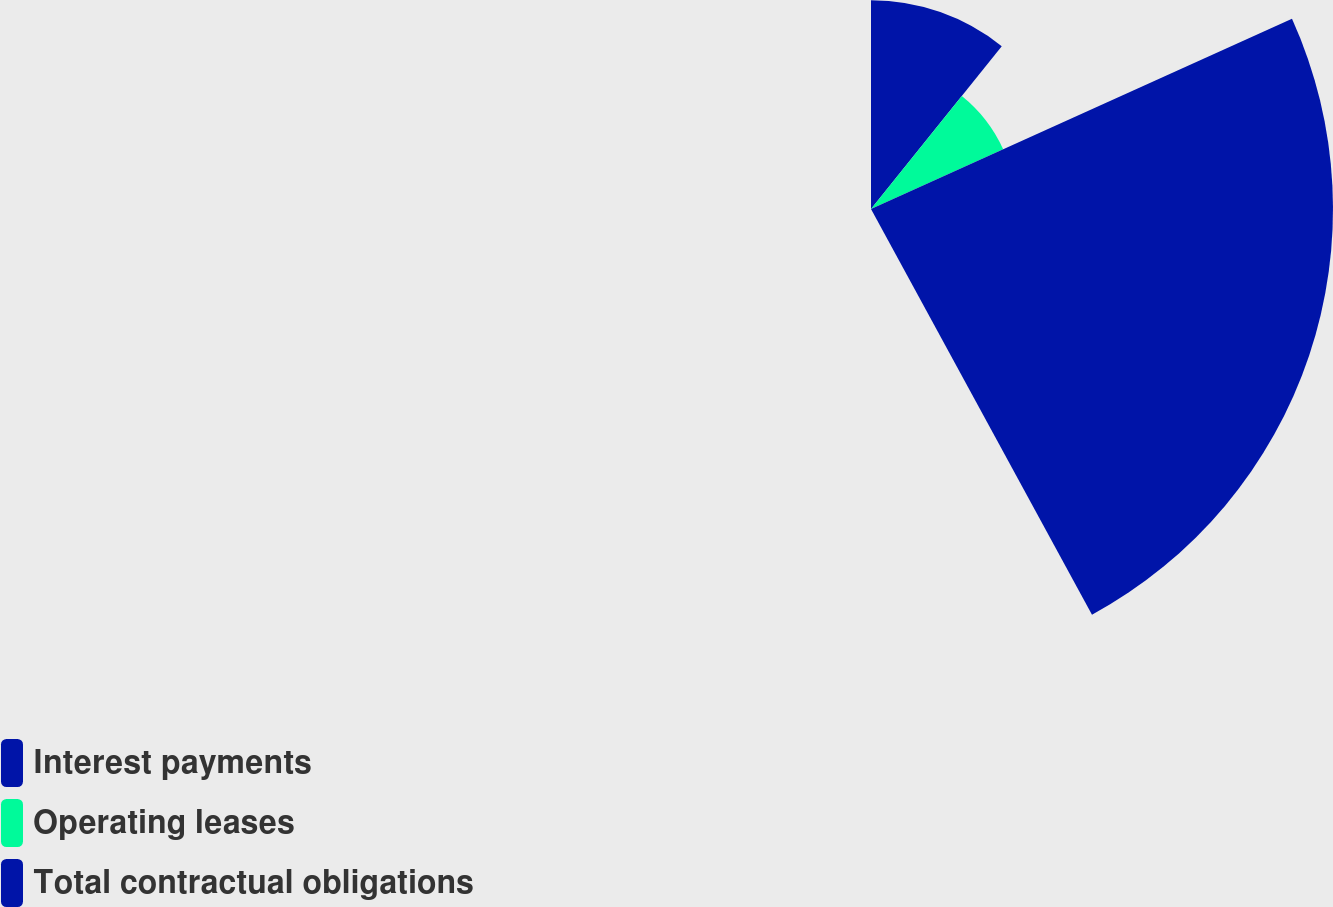Convert chart to OTSL. <chart><loc_0><loc_0><loc_500><loc_500><pie_chart><fcel>Interest payments<fcel>Operating leases<fcel>Total contractual obligations<nl><fcel>25.6%<fcel>17.78%<fcel>56.63%<nl></chart> 